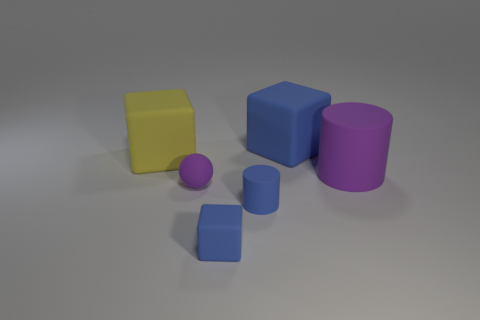How might different textures affect the appearance of these objects? Applying different textures would significantly change the appearance and perceived material quality of these objects. For example, a wood grain texture could make them look like wooden blocks, while a reflective metallic texture could give the impression of metal. Textures add realism and context to 3D objects and can convey information about the object's function, weight, and whether it's new or worn. 